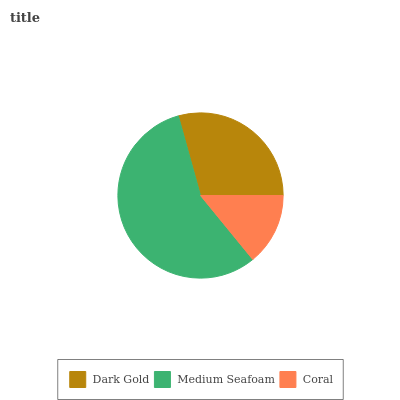Is Coral the minimum?
Answer yes or no. Yes. Is Medium Seafoam the maximum?
Answer yes or no. Yes. Is Medium Seafoam the minimum?
Answer yes or no. No. Is Coral the maximum?
Answer yes or no. No. Is Medium Seafoam greater than Coral?
Answer yes or no. Yes. Is Coral less than Medium Seafoam?
Answer yes or no. Yes. Is Coral greater than Medium Seafoam?
Answer yes or no. No. Is Medium Seafoam less than Coral?
Answer yes or no. No. Is Dark Gold the high median?
Answer yes or no. Yes. Is Dark Gold the low median?
Answer yes or no. Yes. Is Coral the high median?
Answer yes or no. No. Is Medium Seafoam the low median?
Answer yes or no. No. 